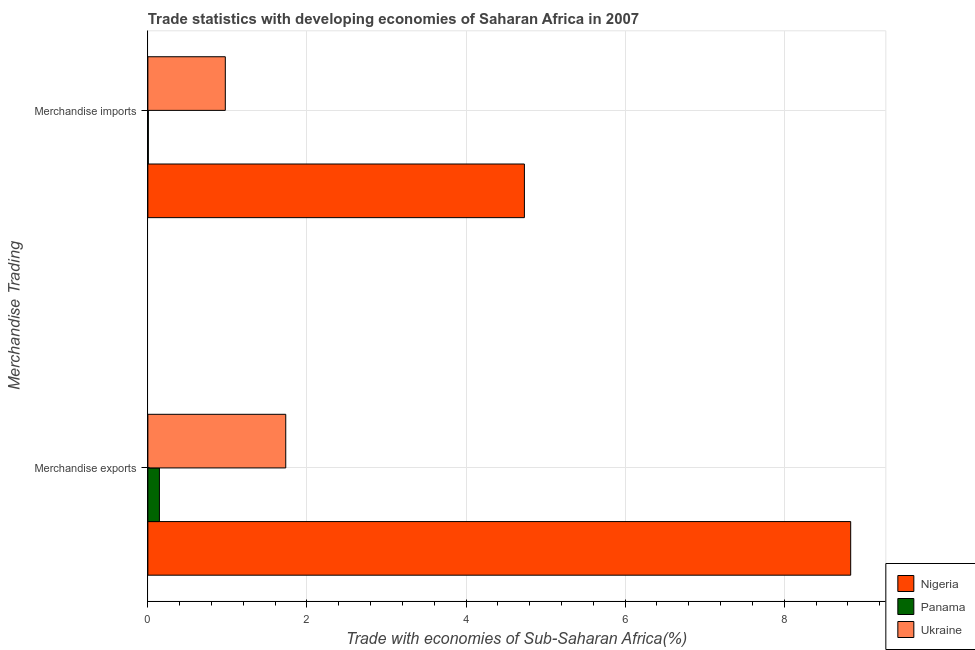How many different coloured bars are there?
Provide a short and direct response. 3. How many groups of bars are there?
Provide a short and direct response. 2. Are the number of bars per tick equal to the number of legend labels?
Provide a succinct answer. Yes. What is the label of the 1st group of bars from the top?
Your answer should be very brief. Merchandise imports. What is the merchandise imports in Nigeria?
Your answer should be compact. 4.73. Across all countries, what is the maximum merchandise exports?
Make the answer very short. 8.83. Across all countries, what is the minimum merchandise imports?
Make the answer very short. 0.01. In which country was the merchandise exports maximum?
Offer a terse response. Nigeria. In which country was the merchandise imports minimum?
Your response must be concise. Panama. What is the total merchandise imports in the graph?
Ensure brevity in your answer.  5.71. What is the difference between the merchandise imports in Nigeria and that in Panama?
Your answer should be very brief. 4.73. What is the difference between the merchandise exports in Ukraine and the merchandise imports in Panama?
Your answer should be very brief. 1.73. What is the average merchandise exports per country?
Your response must be concise. 3.57. What is the difference between the merchandise exports and merchandise imports in Panama?
Your answer should be compact. 0.14. In how many countries, is the merchandise imports greater than 8.8 %?
Provide a short and direct response. 0. What is the ratio of the merchandise imports in Panama to that in Ukraine?
Your answer should be compact. 0.01. In how many countries, is the merchandise imports greater than the average merchandise imports taken over all countries?
Give a very brief answer. 1. What does the 2nd bar from the top in Merchandise imports represents?
Give a very brief answer. Panama. What does the 3rd bar from the bottom in Merchandise imports represents?
Provide a short and direct response. Ukraine. How many bars are there?
Provide a short and direct response. 6. Are all the bars in the graph horizontal?
Your answer should be compact. Yes. Does the graph contain any zero values?
Offer a very short reply. No. Where does the legend appear in the graph?
Your answer should be compact. Bottom right. What is the title of the graph?
Keep it short and to the point. Trade statistics with developing economies of Saharan Africa in 2007. What is the label or title of the X-axis?
Ensure brevity in your answer.  Trade with economies of Sub-Saharan Africa(%). What is the label or title of the Y-axis?
Ensure brevity in your answer.  Merchandise Trading. What is the Trade with economies of Sub-Saharan Africa(%) of Nigeria in Merchandise exports?
Offer a terse response. 8.83. What is the Trade with economies of Sub-Saharan Africa(%) in Panama in Merchandise exports?
Offer a very short reply. 0.15. What is the Trade with economies of Sub-Saharan Africa(%) in Ukraine in Merchandise exports?
Give a very brief answer. 1.73. What is the Trade with economies of Sub-Saharan Africa(%) in Nigeria in Merchandise imports?
Ensure brevity in your answer.  4.73. What is the Trade with economies of Sub-Saharan Africa(%) in Panama in Merchandise imports?
Your answer should be compact. 0.01. What is the Trade with economies of Sub-Saharan Africa(%) of Ukraine in Merchandise imports?
Provide a succinct answer. 0.97. Across all Merchandise Trading, what is the maximum Trade with economies of Sub-Saharan Africa(%) of Nigeria?
Your answer should be compact. 8.83. Across all Merchandise Trading, what is the maximum Trade with economies of Sub-Saharan Africa(%) of Panama?
Offer a terse response. 0.15. Across all Merchandise Trading, what is the maximum Trade with economies of Sub-Saharan Africa(%) of Ukraine?
Offer a terse response. 1.73. Across all Merchandise Trading, what is the minimum Trade with economies of Sub-Saharan Africa(%) of Nigeria?
Make the answer very short. 4.73. Across all Merchandise Trading, what is the minimum Trade with economies of Sub-Saharan Africa(%) of Panama?
Ensure brevity in your answer.  0.01. Across all Merchandise Trading, what is the minimum Trade with economies of Sub-Saharan Africa(%) of Ukraine?
Give a very brief answer. 0.97. What is the total Trade with economies of Sub-Saharan Africa(%) in Nigeria in the graph?
Your answer should be very brief. 13.57. What is the total Trade with economies of Sub-Saharan Africa(%) in Panama in the graph?
Your answer should be compact. 0.15. What is the total Trade with economies of Sub-Saharan Africa(%) in Ukraine in the graph?
Your response must be concise. 2.71. What is the difference between the Trade with economies of Sub-Saharan Africa(%) of Nigeria in Merchandise exports and that in Merchandise imports?
Give a very brief answer. 4.1. What is the difference between the Trade with economies of Sub-Saharan Africa(%) of Panama in Merchandise exports and that in Merchandise imports?
Keep it short and to the point. 0.14. What is the difference between the Trade with economies of Sub-Saharan Africa(%) in Ukraine in Merchandise exports and that in Merchandise imports?
Your response must be concise. 0.76. What is the difference between the Trade with economies of Sub-Saharan Africa(%) in Nigeria in Merchandise exports and the Trade with economies of Sub-Saharan Africa(%) in Panama in Merchandise imports?
Provide a succinct answer. 8.83. What is the difference between the Trade with economies of Sub-Saharan Africa(%) of Nigeria in Merchandise exports and the Trade with economies of Sub-Saharan Africa(%) of Ukraine in Merchandise imports?
Keep it short and to the point. 7.86. What is the difference between the Trade with economies of Sub-Saharan Africa(%) of Panama in Merchandise exports and the Trade with economies of Sub-Saharan Africa(%) of Ukraine in Merchandise imports?
Provide a short and direct response. -0.83. What is the average Trade with economies of Sub-Saharan Africa(%) of Nigeria per Merchandise Trading?
Ensure brevity in your answer.  6.78. What is the average Trade with economies of Sub-Saharan Africa(%) in Panama per Merchandise Trading?
Offer a very short reply. 0.08. What is the average Trade with economies of Sub-Saharan Africa(%) of Ukraine per Merchandise Trading?
Your answer should be compact. 1.35. What is the difference between the Trade with economies of Sub-Saharan Africa(%) in Nigeria and Trade with economies of Sub-Saharan Africa(%) in Panama in Merchandise exports?
Provide a short and direct response. 8.69. What is the difference between the Trade with economies of Sub-Saharan Africa(%) in Nigeria and Trade with economies of Sub-Saharan Africa(%) in Ukraine in Merchandise exports?
Provide a succinct answer. 7.1. What is the difference between the Trade with economies of Sub-Saharan Africa(%) in Panama and Trade with economies of Sub-Saharan Africa(%) in Ukraine in Merchandise exports?
Offer a very short reply. -1.59. What is the difference between the Trade with economies of Sub-Saharan Africa(%) in Nigeria and Trade with economies of Sub-Saharan Africa(%) in Panama in Merchandise imports?
Ensure brevity in your answer.  4.73. What is the difference between the Trade with economies of Sub-Saharan Africa(%) of Nigeria and Trade with economies of Sub-Saharan Africa(%) of Ukraine in Merchandise imports?
Make the answer very short. 3.76. What is the difference between the Trade with economies of Sub-Saharan Africa(%) in Panama and Trade with economies of Sub-Saharan Africa(%) in Ukraine in Merchandise imports?
Your answer should be very brief. -0.97. What is the ratio of the Trade with economies of Sub-Saharan Africa(%) in Nigeria in Merchandise exports to that in Merchandise imports?
Offer a terse response. 1.87. What is the ratio of the Trade with economies of Sub-Saharan Africa(%) in Panama in Merchandise exports to that in Merchandise imports?
Provide a succinct answer. 24.71. What is the ratio of the Trade with economies of Sub-Saharan Africa(%) in Ukraine in Merchandise exports to that in Merchandise imports?
Your response must be concise. 1.78. What is the difference between the highest and the second highest Trade with economies of Sub-Saharan Africa(%) of Nigeria?
Provide a short and direct response. 4.1. What is the difference between the highest and the second highest Trade with economies of Sub-Saharan Africa(%) in Panama?
Your response must be concise. 0.14. What is the difference between the highest and the second highest Trade with economies of Sub-Saharan Africa(%) of Ukraine?
Give a very brief answer. 0.76. What is the difference between the highest and the lowest Trade with economies of Sub-Saharan Africa(%) in Nigeria?
Offer a very short reply. 4.1. What is the difference between the highest and the lowest Trade with economies of Sub-Saharan Africa(%) in Panama?
Offer a terse response. 0.14. What is the difference between the highest and the lowest Trade with economies of Sub-Saharan Africa(%) in Ukraine?
Make the answer very short. 0.76. 